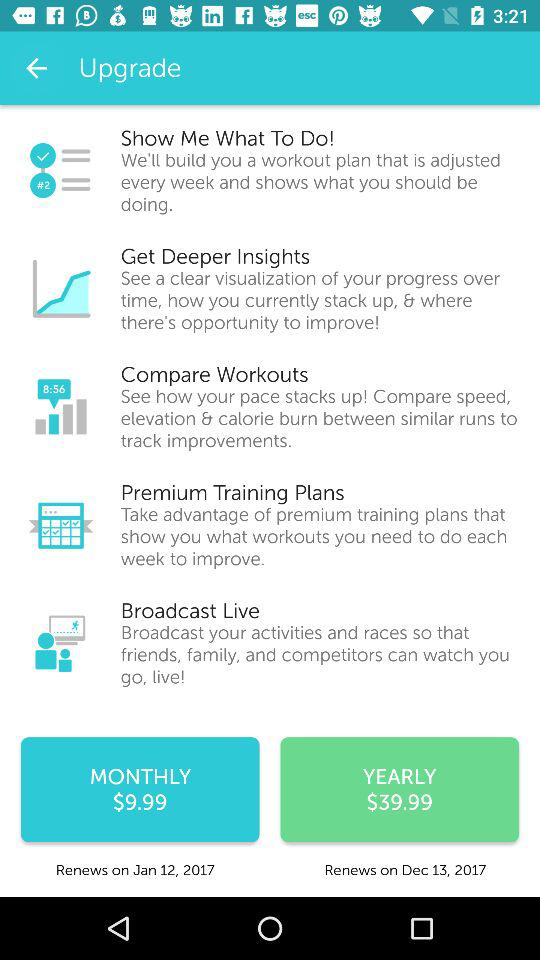How many different payment options are available?
Answer the question using a single word or phrase. 2 